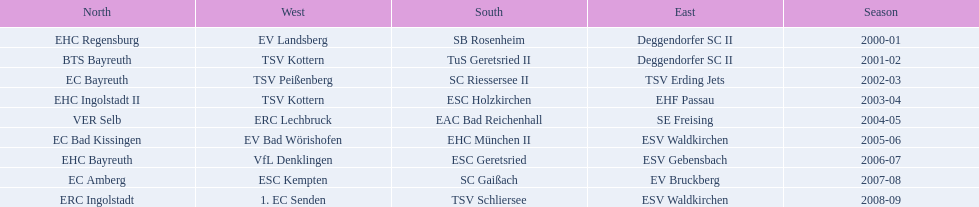Which teams played in the north? EHC Regensburg, BTS Bayreuth, EC Bayreuth, EHC Ingolstadt II, VER Selb, EC Bad Kissingen, EHC Bayreuth, EC Amberg, ERC Ingolstadt. Of these teams, which played during 2000-2001? EHC Regensburg. 